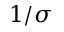Convert formula to latex. <formula><loc_0><loc_0><loc_500><loc_500>1 / \sigma</formula> 